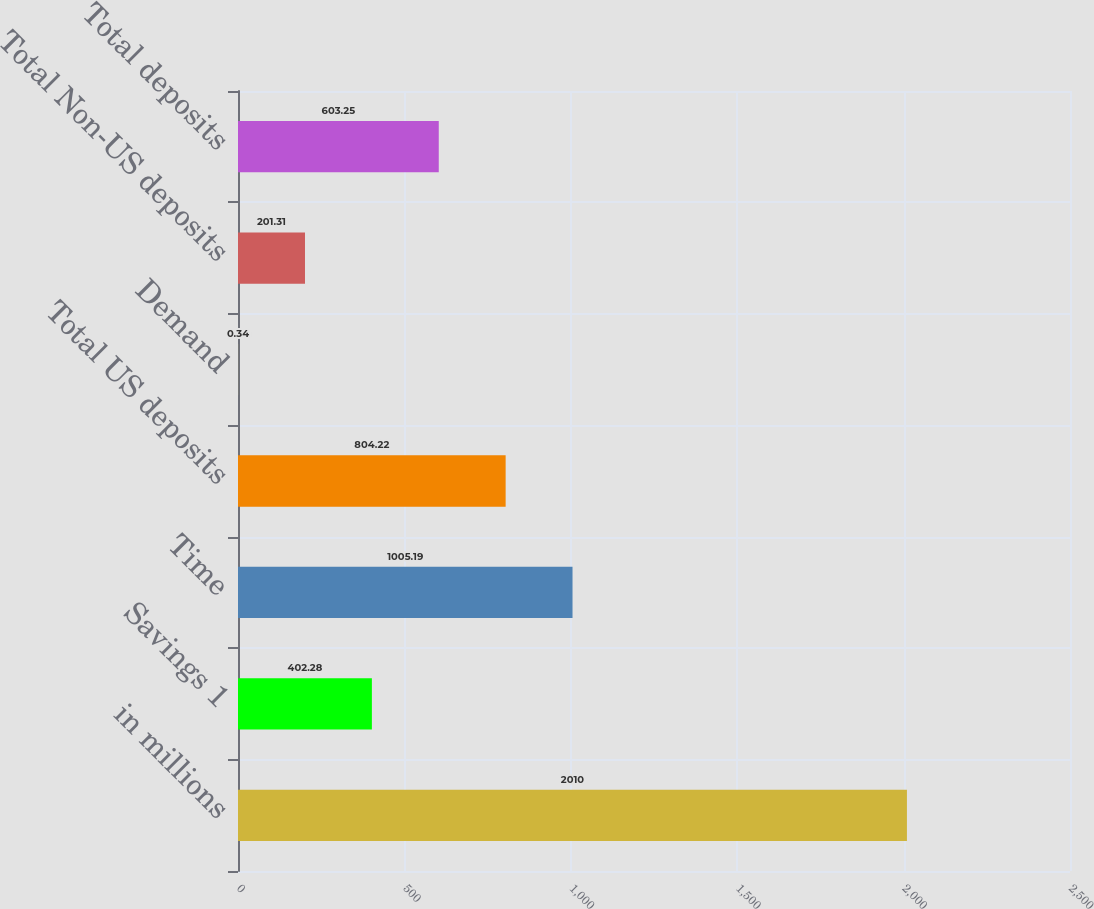<chart> <loc_0><loc_0><loc_500><loc_500><bar_chart><fcel>in millions<fcel>Savings 1<fcel>Time<fcel>Total US deposits<fcel>Demand<fcel>Total Non-US deposits<fcel>Total deposits<nl><fcel>2010<fcel>402.28<fcel>1005.19<fcel>804.22<fcel>0.34<fcel>201.31<fcel>603.25<nl></chart> 